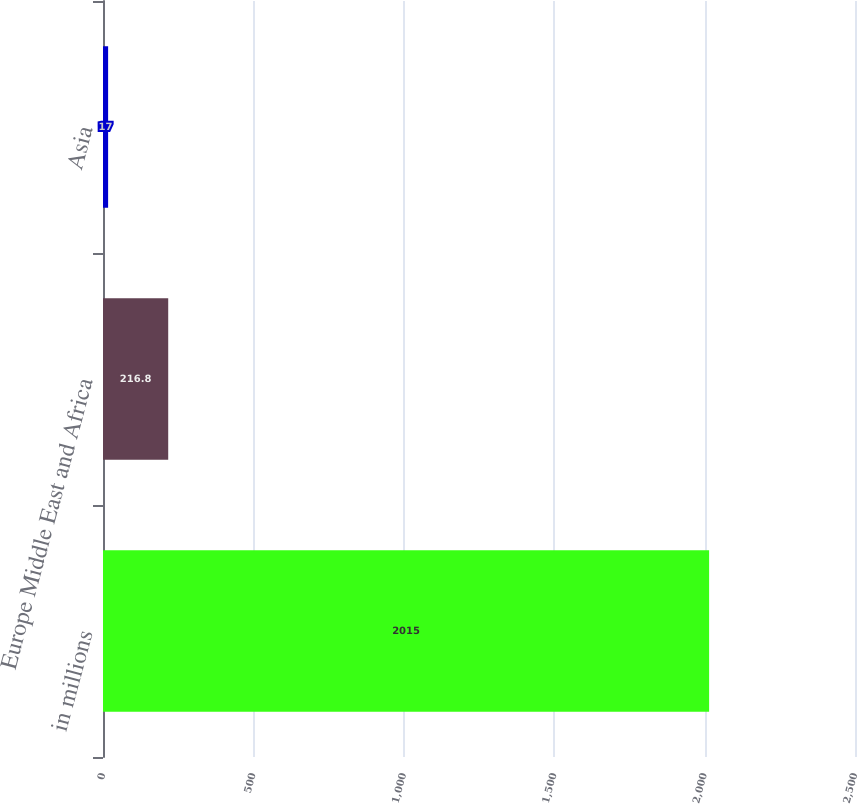Convert chart. <chart><loc_0><loc_0><loc_500><loc_500><bar_chart><fcel>in millions<fcel>Europe Middle East and Africa<fcel>Asia<nl><fcel>2015<fcel>216.8<fcel>17<nl></chart> 